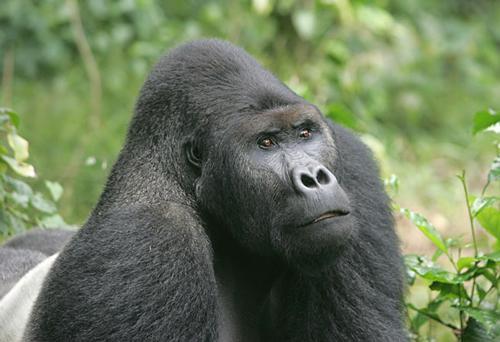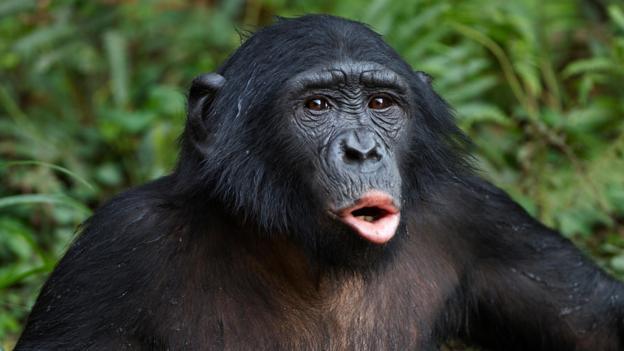The first image is the image on the left, the second image is the image on the right. Considering the images on both sides, is "There is one gorilla with its mouth wide open showing all of its teeth." valid? Answer yes or no. No. The first image is the image on the left, the second image is the image on the right. Assess this claim about the two images: "Each image shows just one ape, and one of the apes has an open mouth.". Correct or not? Answer yes or no. Yes. 